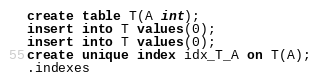Convert code to text. <code><loc_0><loc_0><loc_500><loc_500><_SQL_>create table T(A int);
insert into T values(0);
insert into T values(0);
create unique index idx_T_A on T(A);
.indexes

</code> 